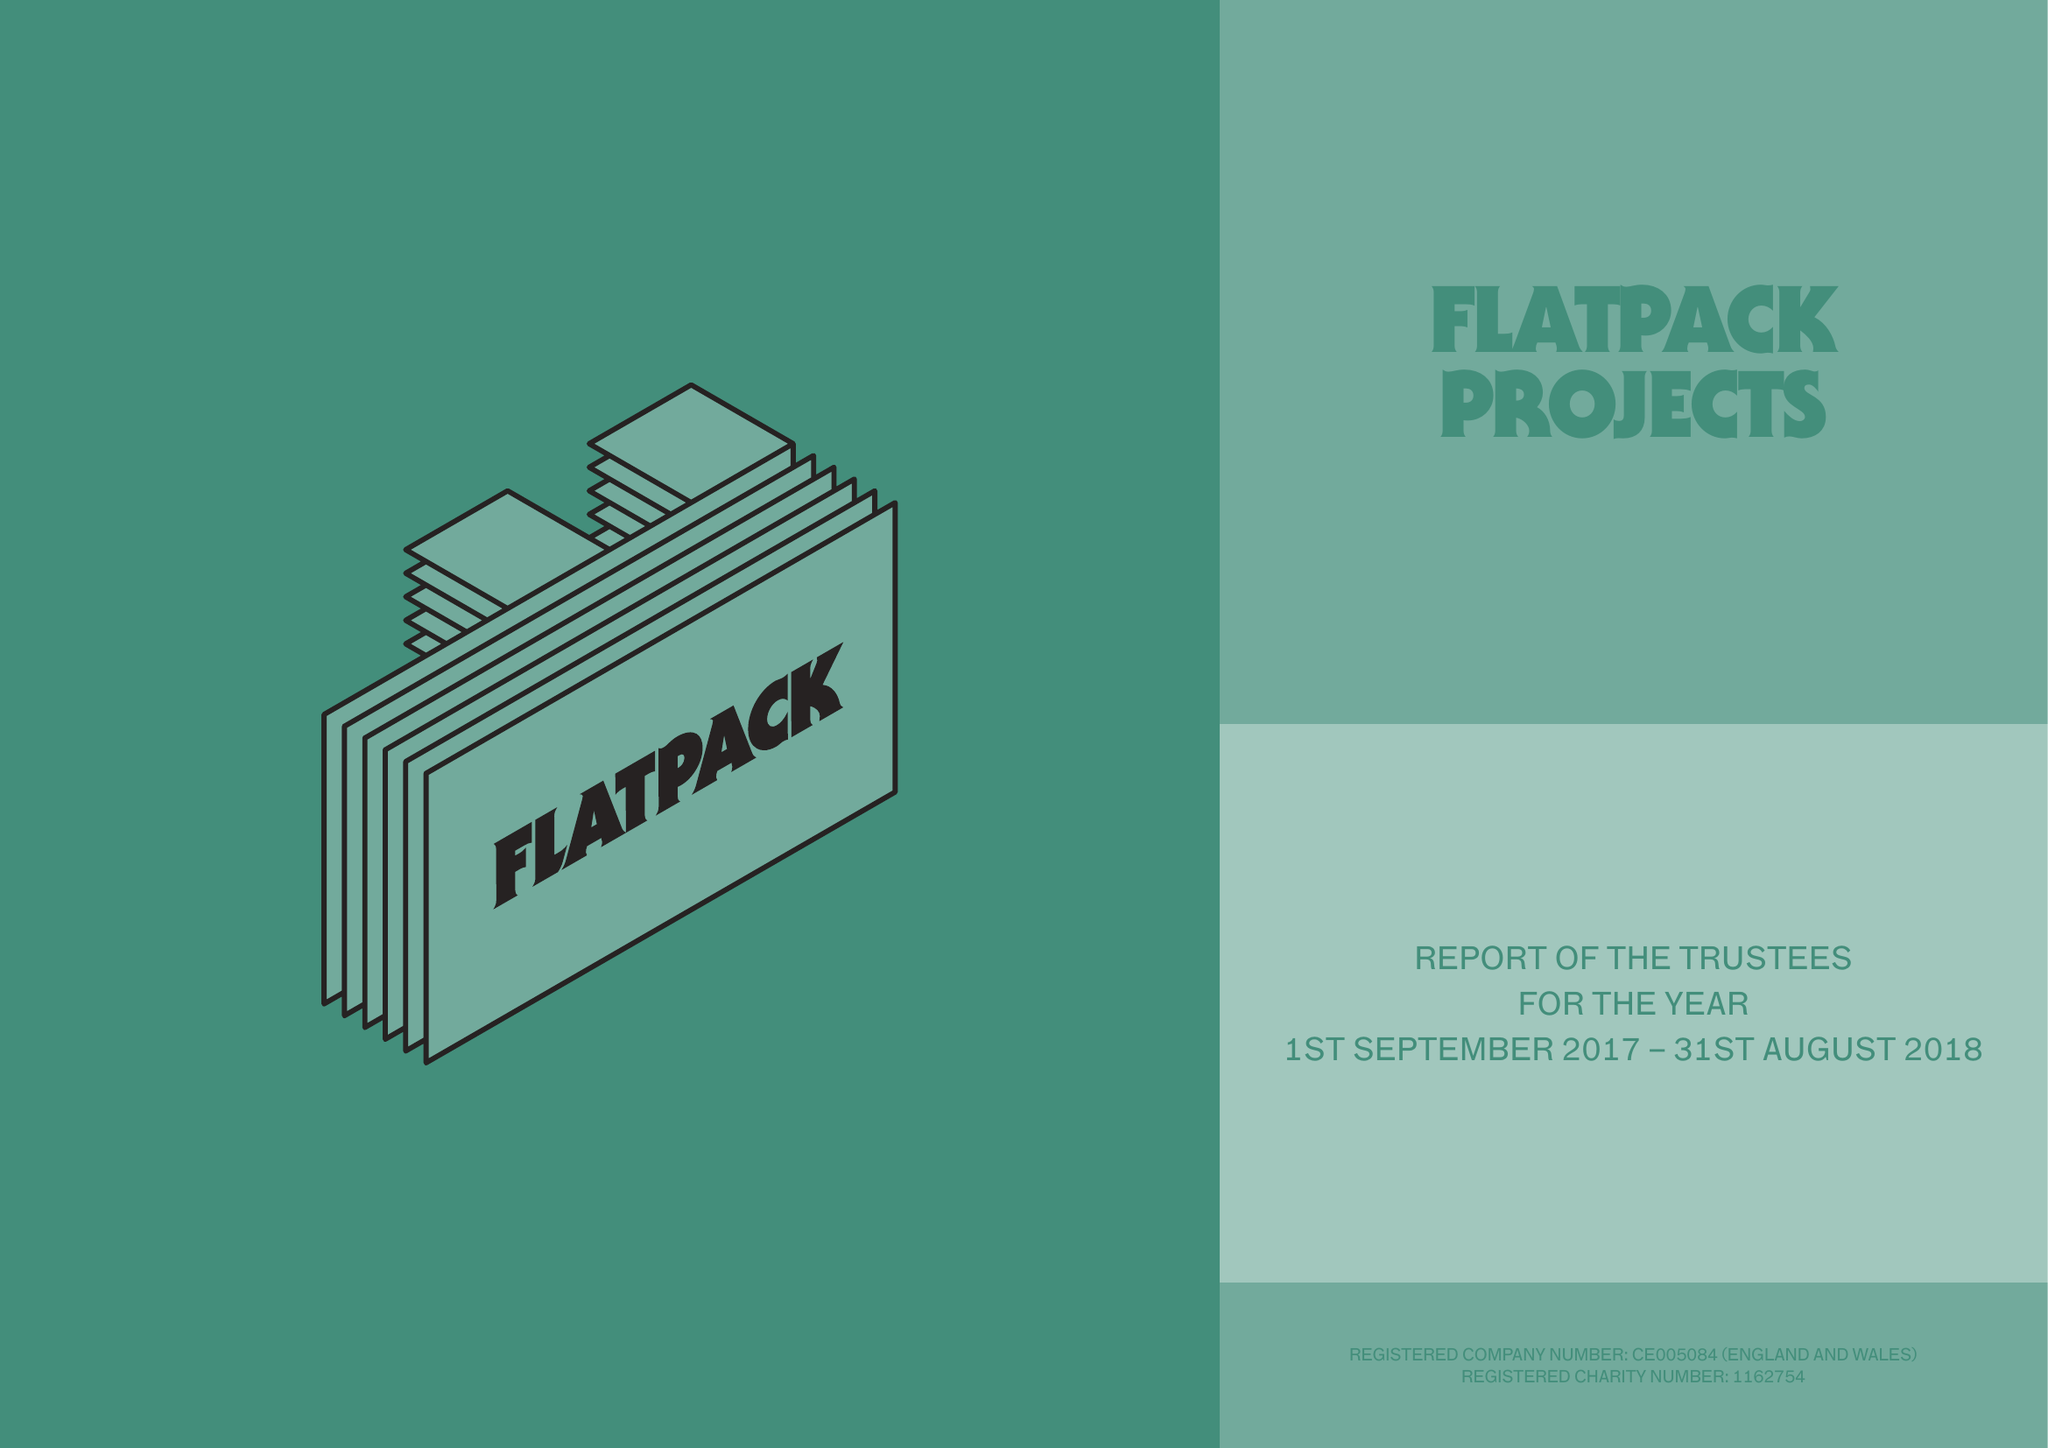What is the value for the address__post_town?
Answer the question using a single word or phrase. BIRMINGHAM 